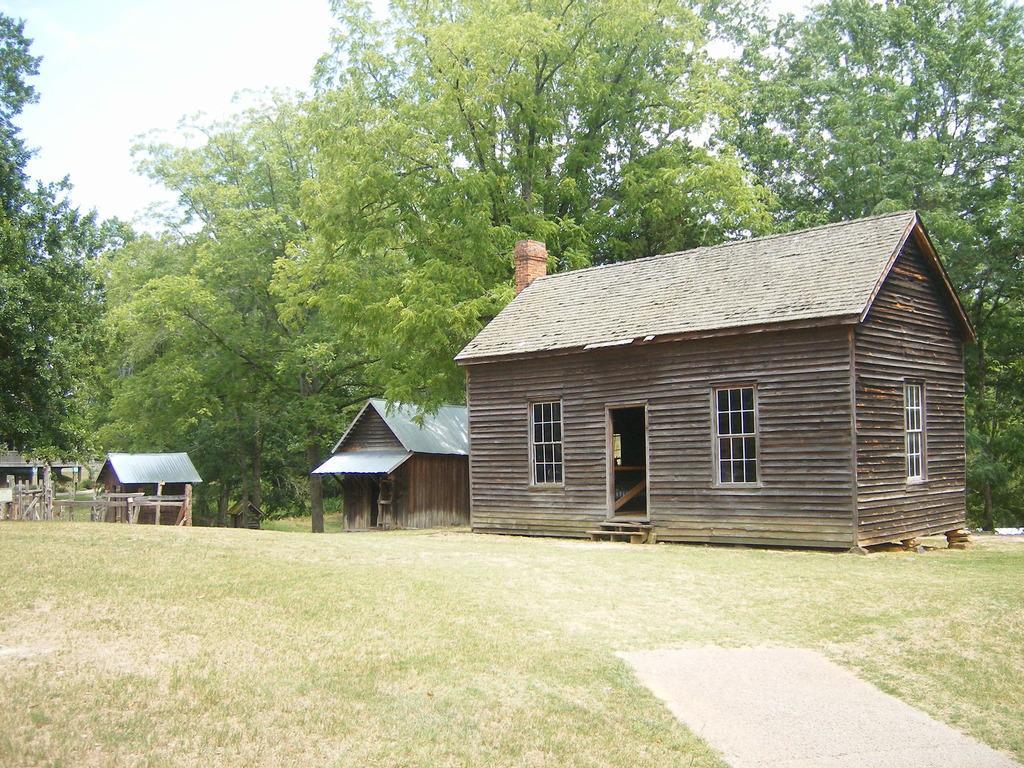How would you summarize this image in a sentence or two? In this image we can see some houses with roof and windows. We can also see grass, a group of trees and the sky. 